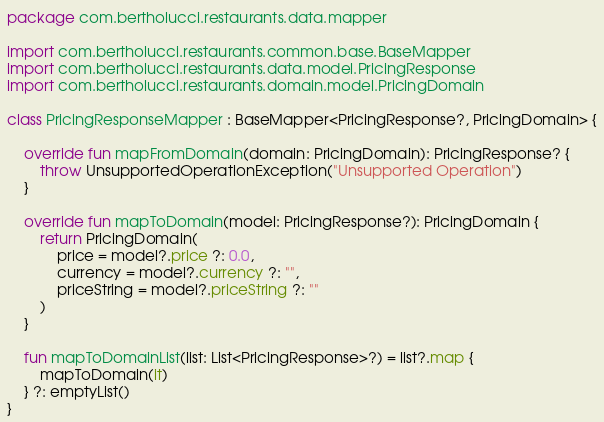Convert code to text. <code><loc_0><loc_0><loc_500><loc_500><_Kotlin_>package com.bertholucci.restaurants.data.mapper

import com.bertholucci.restaurants.common.base.BaseMapper
import com.bertholucci.restaurants.data.model.PricingResponse
import com.bertholucci.restaurants.domain.model.PricingDomain

class PricingResponseMapper : BaseMapper<PricingResponse?, PricingDomain> {

    override fun mapFromDomain(domain: PricingDomain): PricingResponse? {
        throw UnsupportedOperationException("Unsupported Operation")
    }

    override fun mapToDomain(model: PricingResponse?): PricingDomain {
        return PricingDomain(
            price = model?.price ?: 0.0,
            currency = model?.currency ?: "",
            priceString = model?.priceString ?: ""
        )
    }

    fun mapToDomainList(list: List<PricingResponse>?) = list?.map {
        mapToDomain(it)
    } ?: emptyList()
}</code> 